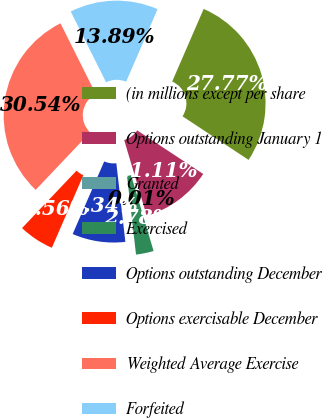Convert chart to OTSL. <chart><loc_0><loc_0><loc_500><loc_500><pie_chart><fcel>(in millions except per share<fcel>Options outstanding January 1<fcel>Granted<fcel>Exercised<fcel>Options outstanding December<fcel>Options exercisable December<fcel>Weighted Average Exercise<fcel>Forfeited<nl><fcel>27.77%<fcel>11.11%<fcel>0.01%<fcel>2.78%<fcel>8.34%<fcel>5.56%<fcel>30.54%<fcel>13.89%<nl></chart> 